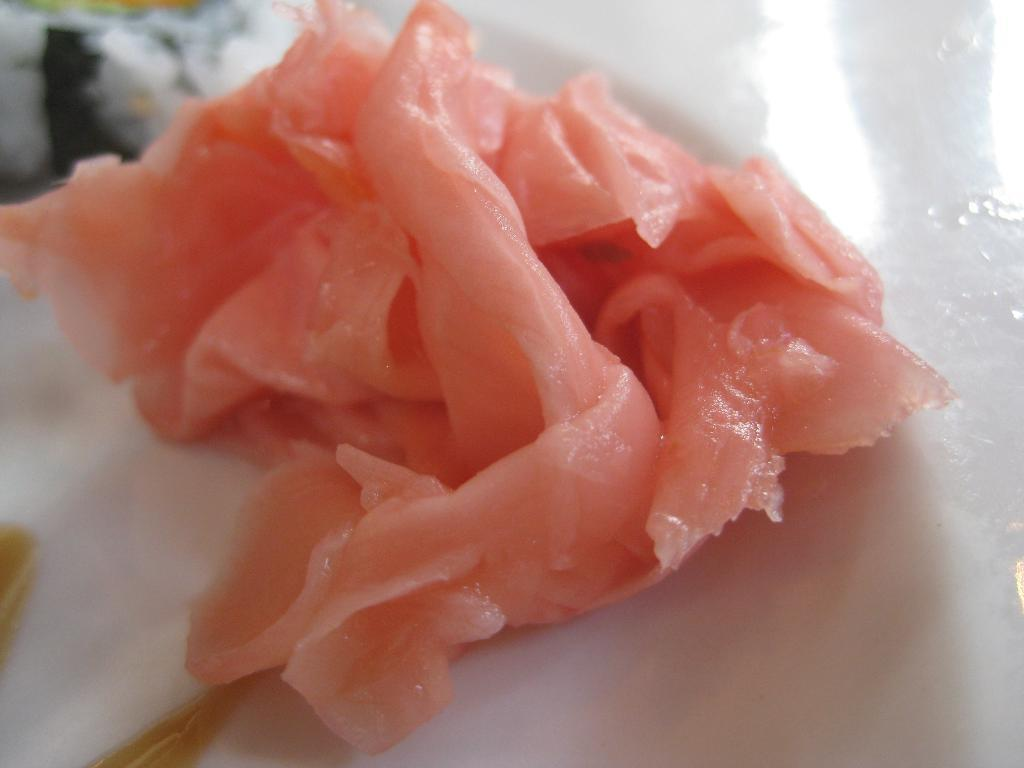What type of food is visible in the image? There is meat in the image. On what surface is the meat placed? The meat is on a white surface. What songs are being played in the background of the image? There is no information about songs being played in the image, as it only features meat on a white surface. Is there a cable visible in the image? There is no cable present in the image. 